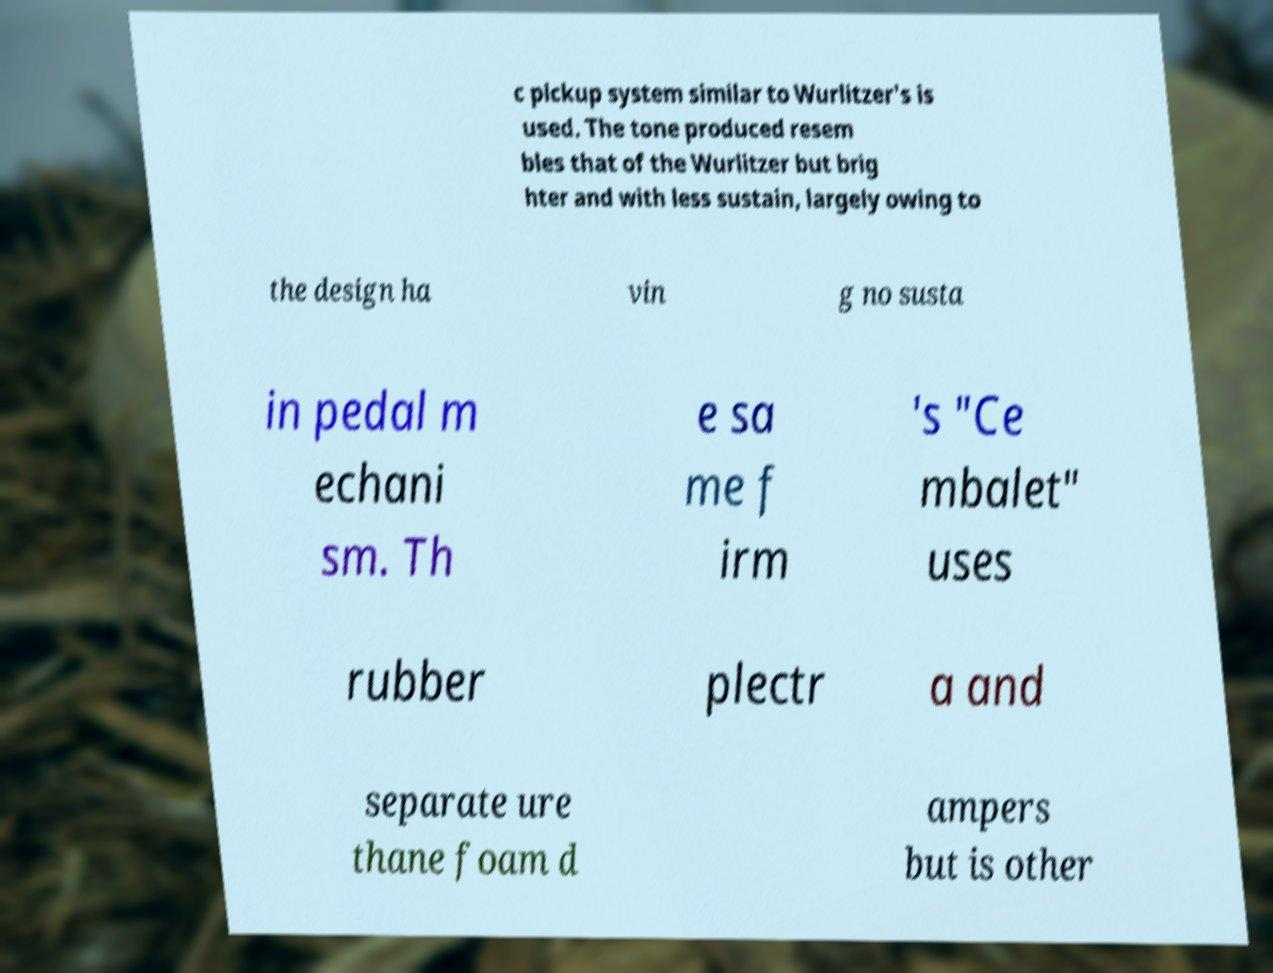There's text embedded in this image that I need extracted. Can you transcribe it verbatim? c pickup system similar to Wurlitzer's is used. The tone produced resem bles that of the Wurlitzer but brig hter and with less sustain, largely owing to the design ha vin g no susta in pedal m echani sm. Th e sa me f irm 's "Ce mbalet" uses rubber plectr a and separate ure thane foam d ampers but is other 